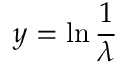Convert formula to latex. <formula><loc_0><loc_0><loc_500><loc_500>y = \ln { \frac { 1 } { \lambda } }</formula> 